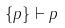<formula> <loc_0><loc_0><loc_500><loc_500>{ \{ p \} \vdash p }</formula> 